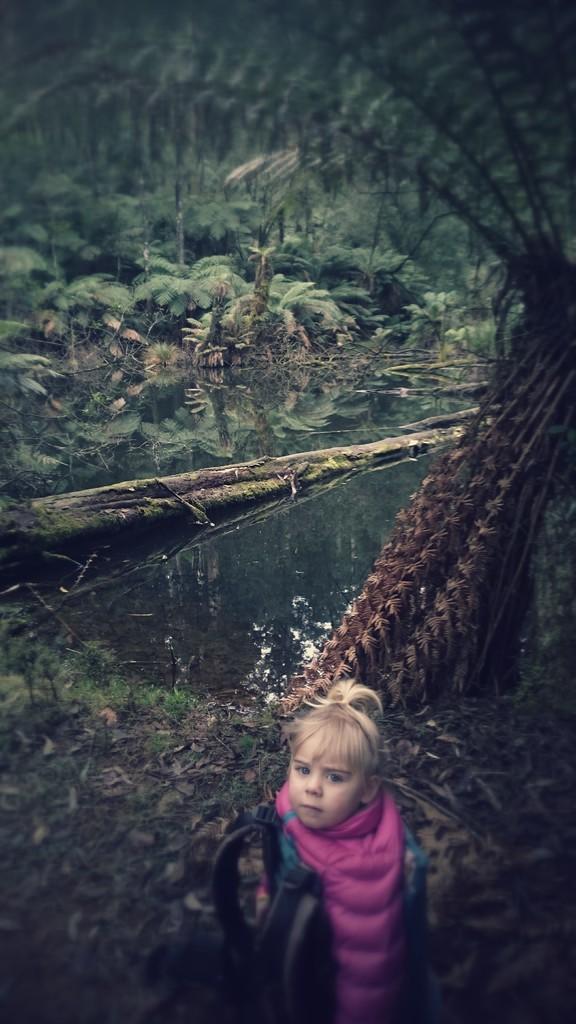Please provide a concise description of this image. In this image at the bottom, there is a girl, she wears a dress. In the middle there are plants, trees, water, land. 